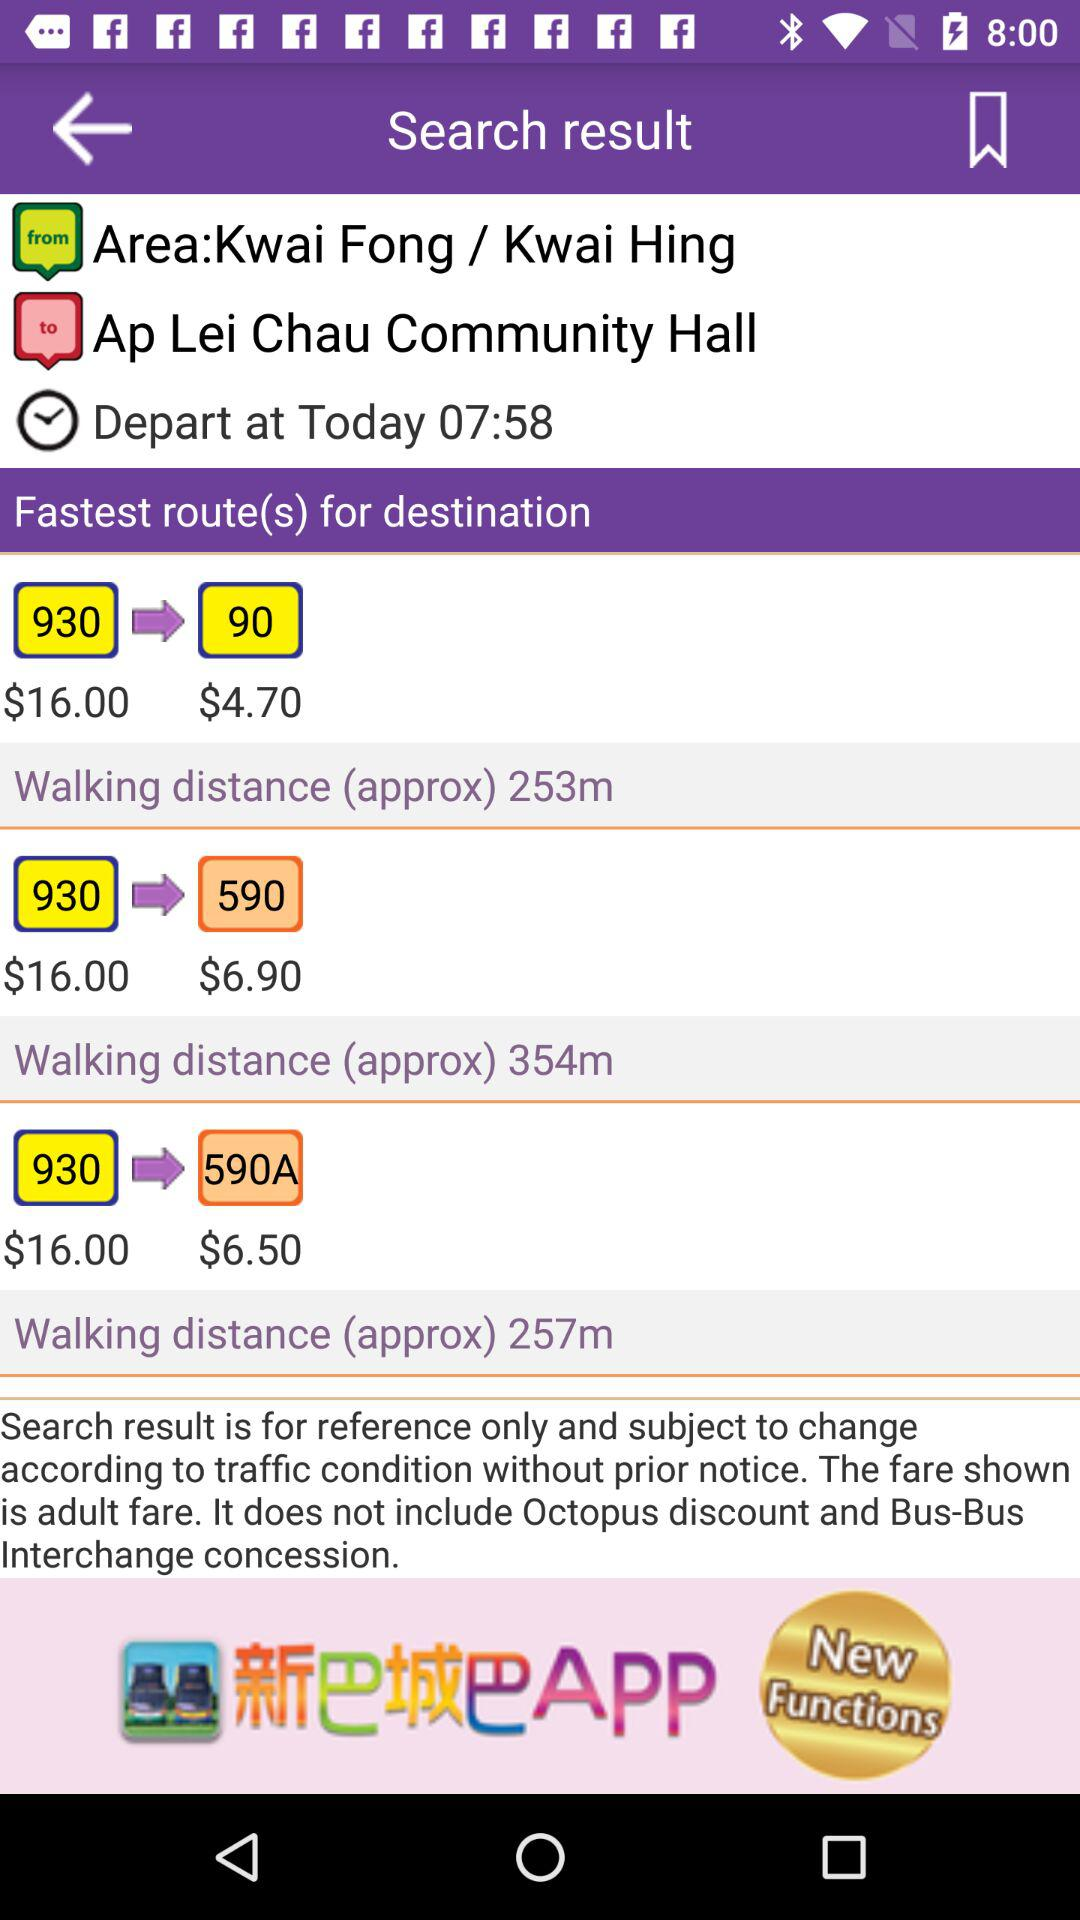What is the departure time? The departure time is 07:58. 